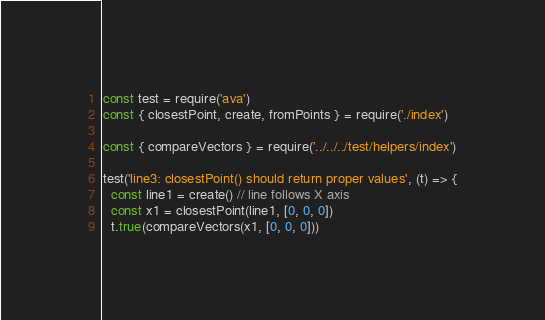Convert code to text. <code><loc_0><loc_0><loc_500><loc_500><_JavaScript_>const test = require('ava')
const { closestPoint, create, fromPoints } = require('./index')

const { compareVectors } = require('../../../test/helpers/index')

test('line3: closestPoint() should return proper values', (t) => {
  const line1 = create() // line follows X axis
  const x1 = closestPoint(line1, [0, 0, 0])
  t.true(compareVectors(x1, [0, 0, 0]))</code> 